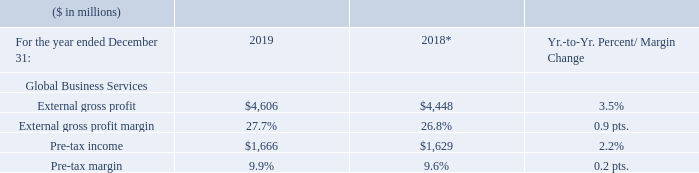The GBS profit margin increased 0.9 points to 27.7 percent and pre-tax income of $1,666 million increased 2.2 percent year to year. The pre-tax margin of 9.9 percent increased slightly year to year. The year-to-year improvements in margins and pre-tax income were driven by the continued mix shift to higher-value offerings, the yield from delivery productivity improvements and a currency benefit from leveraging the global delivery resource model. We continued to invest in our services offerings and skills necessary to assist our clients on their cloud journey.
* Recast to reflect segment changes.
What caused the decrease in the pre-tax income in 2019? The year-to-year improvements in margins and pre-tax income were driven by the continued mix shift to higher-value offerings, the yield from delivery productivity improvements and a currency benefit from leveraging the global delivery resource model. What was the pre-tax margin of 2019? 9.9%. What was the External gross profit margin in 2019? 27.7%. What were the average External total gross profit?
Answer scale should be: million. (4,606+4,448) / 2
Answer: 4527. What was the increase / (decrease) in the Pre-tax income from 2018 to 2019?
Answer scale should be: million. 1,666 - 1,629
Answer: 37. What was the increase / (decrease) in the Pre-tax margin from 2018 to 2019?
Answer scale should be: percent. 9.9% - 9.6%
Answer: 0.3. 